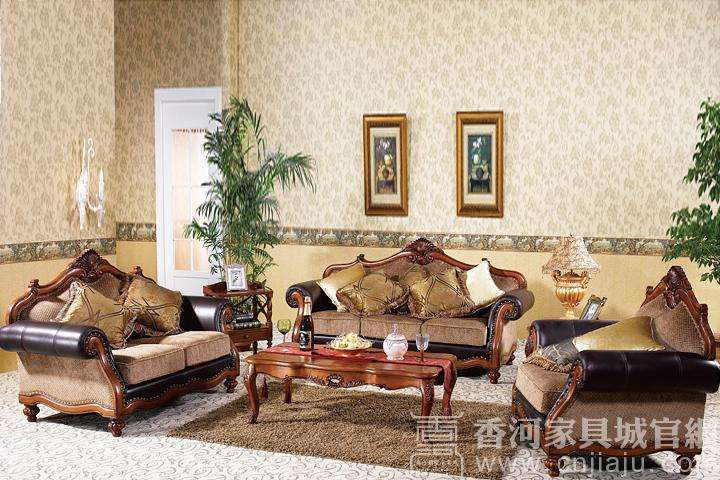Is the plant in the corner real or artificial? Without being able to examine the plant closely and given it's an image, it's difficult to determine with certainty whether the plant is real or artificial. However, considering the setting and the appearance, one could hypothesize that an artificial plant might be used in such a decor to provide consistent aesthetic appeal without the maintenance required by a real plant. 